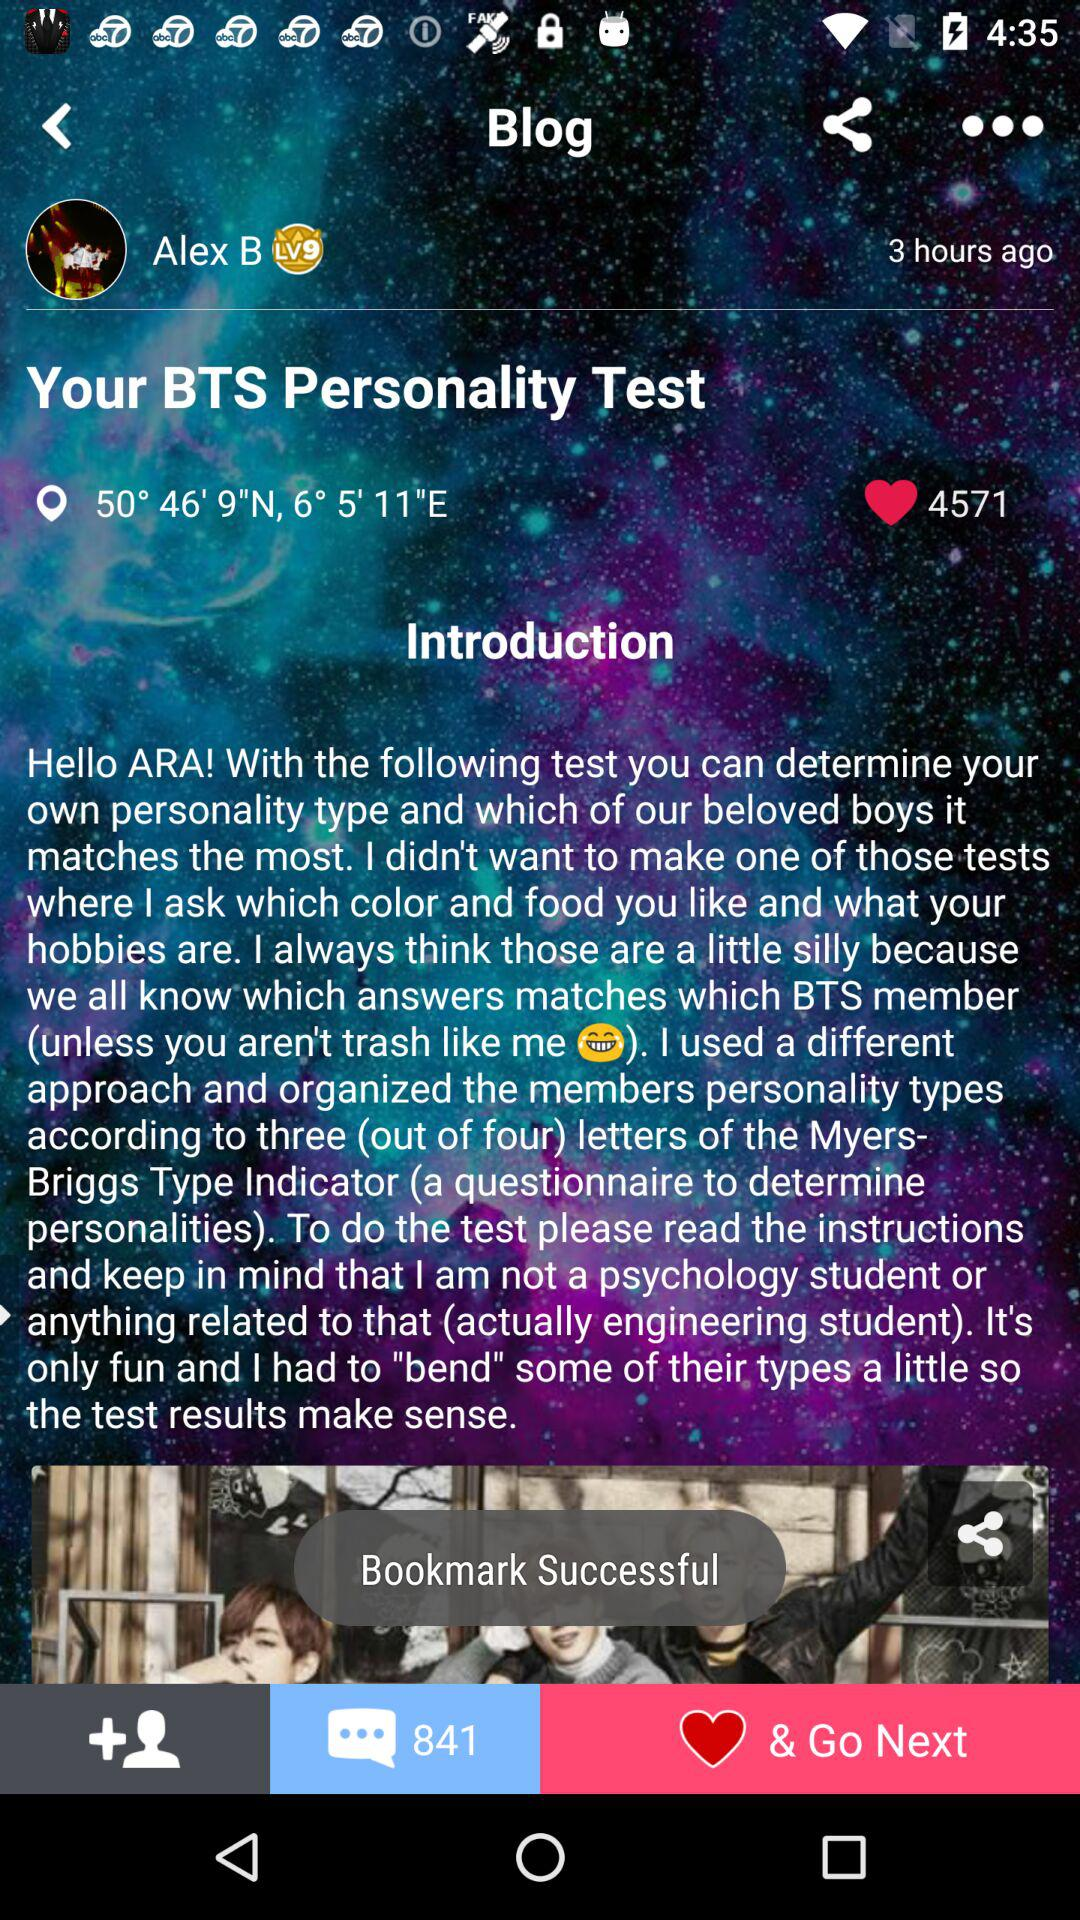Who has written the blog? The blog has been written by Alex B. 